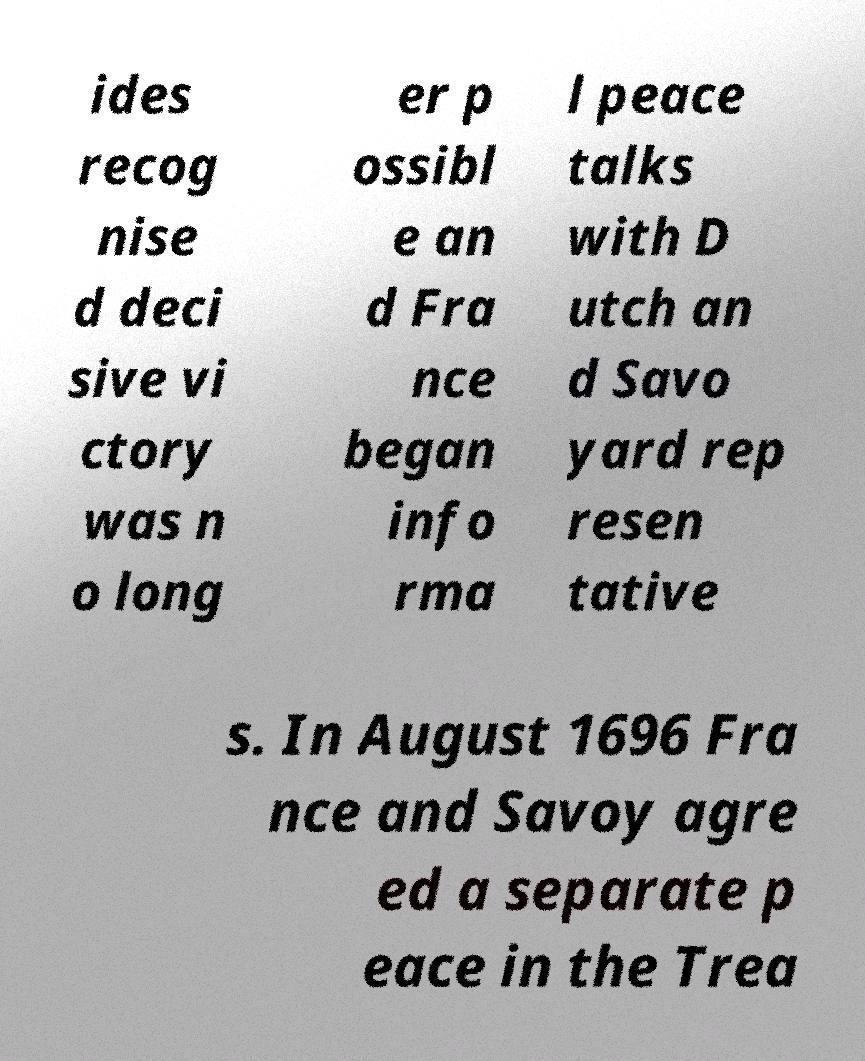Could you extract and type out the text from this image? ides recog nise d deci sive vi ctory was n o long er p ossibl e an d Fra nce began info rma l peace talks with D utch an d Savo yard rep resen tative s. In August 1696 Fra nce and Savoy agre ed a separate p eace in the Trea 